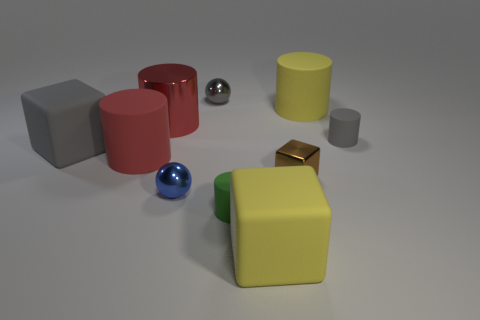Can you infer any particular use for the objects shown? These objects might be used in visual arts as basic 3D models for teaching shading and perspective, in a children's game for learning about shapes and colors, or as assets in a computer graphics project. How could these objects be useful in teaching shading and perspective? The different shapes and sizes of these objects provide a variety of angles and surfaces for light to interact with. This is ideal for demonstrating how light affects color and form, and for teaching artists to render shadows and highlights, which are crucial for creating a sense of depth in a drawing or painting. 